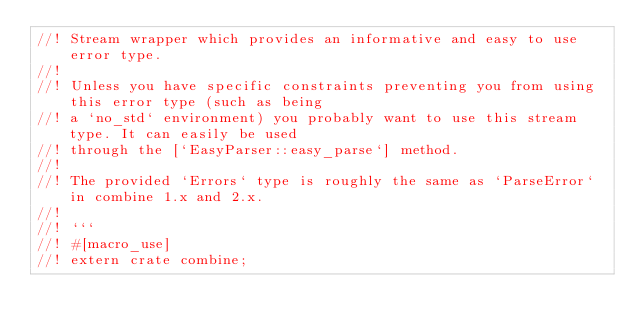<code> <loc_0><loc_0><loc_500><loc_500><_Rust_>//! Stream wrapper which provides an informative and easy to use error type.
//!
//! Unless you have specific constraints preventing you from using this error type (such as being
//! a `no_std` environment) you probably want to use this stream type. It can easily be used
//! through the [`EasyParser::easy_parse`] method.
//!
//! The provided `Errors` type is roughly the same as `ParseError` in combine 1.x and 2.x.
//!
//! ```
//! #[macro_use]
//! extern crate combine;</code> 